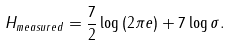Convert formula to latex. <formula><loc_0><loc_0><loc_500><loc_500>H _ { m e a s u r e d } = \frac { 7 } { 2 } \log \left ( 2 \pi e \right ) + 7 \log \sigma .</formula> 